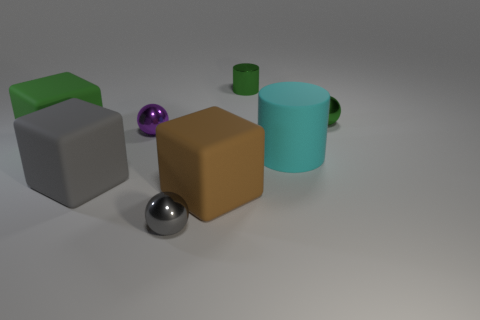What number of gray things are tiny metal balls or large cubes?
Your answer should be very brief. 2. There is a cube that is both in front of the big green matte object and left of the tiny purple metal thing; what is its material?
Ensure brevity in your answer.  Rubber. Is the material of the green ball the same as the big cylinder?
Offer a very short reply. No. What number of rubber things are the same size as the cyan matte cylinder?
Offer a terse response. 3. Is the number of big brown objects that are to the left of the small purple shiny thing the same as the number of green metallic cylinders?
Provide a short and direct response. No. What number of rubber things are both behind the large gray block and on the left side of the purple object?
Offer a terse response. 1. There is a tiny metal object that is in front of the small purple ball; is it the same shape as the big gray object?
Keep it short and to the point. No. There is a gray thing that is the same size as the green matte object; what material is it?
Offer a very short reply. Rubber. Are there the same number of brown blocks in front of the brown matte object and cyan rubber objects that are in front of the gray metallic object?
Your answer should be very brief. Yes. How many balls are on the left side of the tiny green metal thing in front of the tiny green metal object behind the small green ball?
Your response must be concise. 2. 